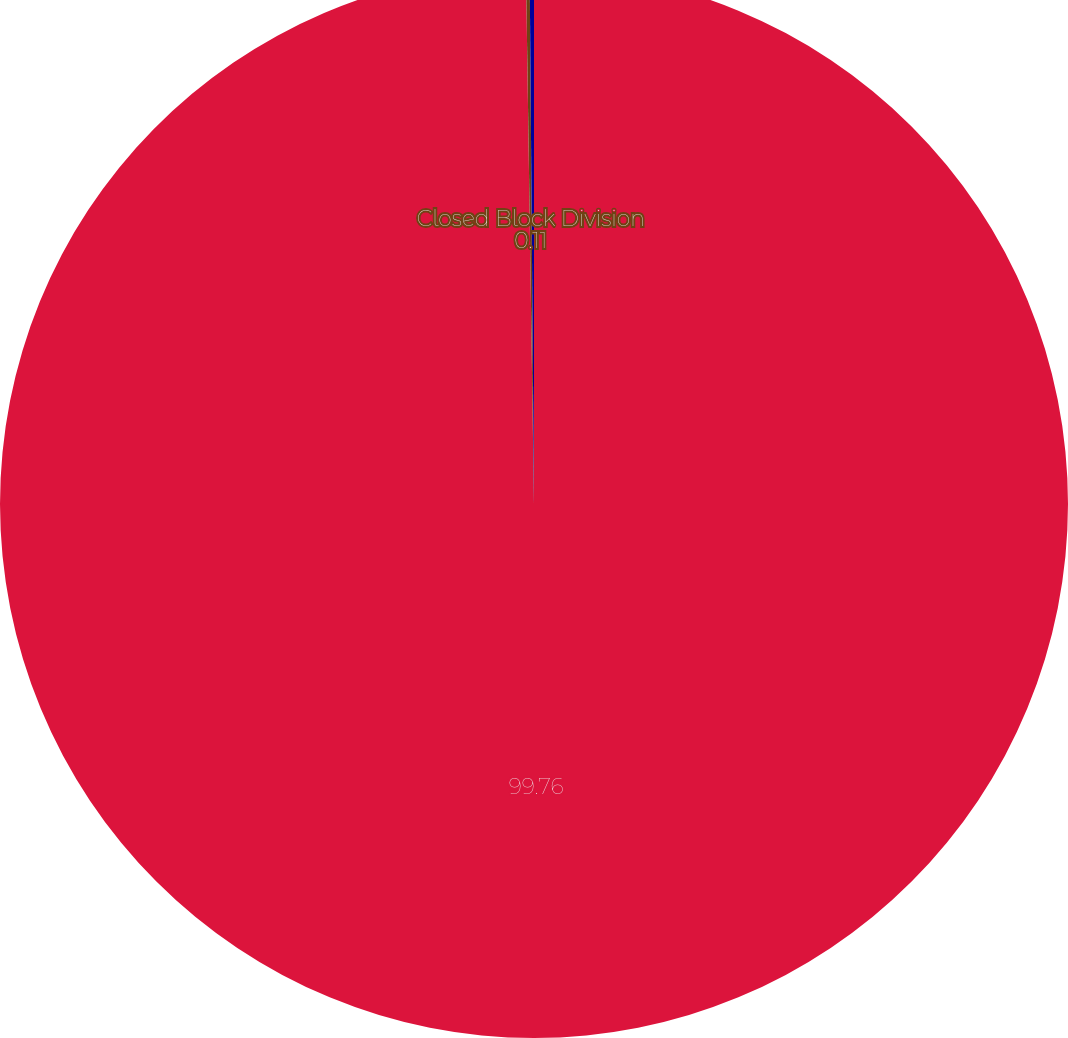<chart> <loc_0><loc_0><loc_500><loc_500><pie_chart><ecel><fcel>Closed Block Division<fcel>PFI Excluding Closed Block Division<nl><fcel>99.76%<fcel>0.11%<fcel>0.13%<nl></chart> 